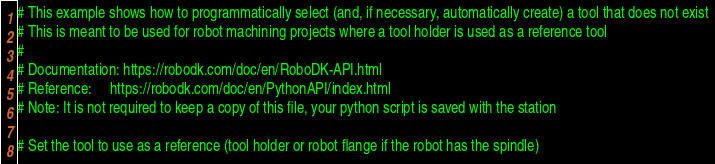Convert code to text. <code><loc_0><loc_0><loc_500><loc_500><_Python_># This example shows how to programmatically select (and, if necessary, automatically create) a tool that does not exist
# This is meant to be used for robot machining projects where a tool holder is used as a reference tool
# 
# Documentation: https://robodk.com/doc/en/RoboDK-API.html
# Reference:     https://robodk.com/doc/en/PythonAPI/index.html
# Note: It is not required to keep a copy of this file, your python script is saved with the station

# Set the tool to use as a reference (tool holder or robot flange if the robot has the spindle)</code> 